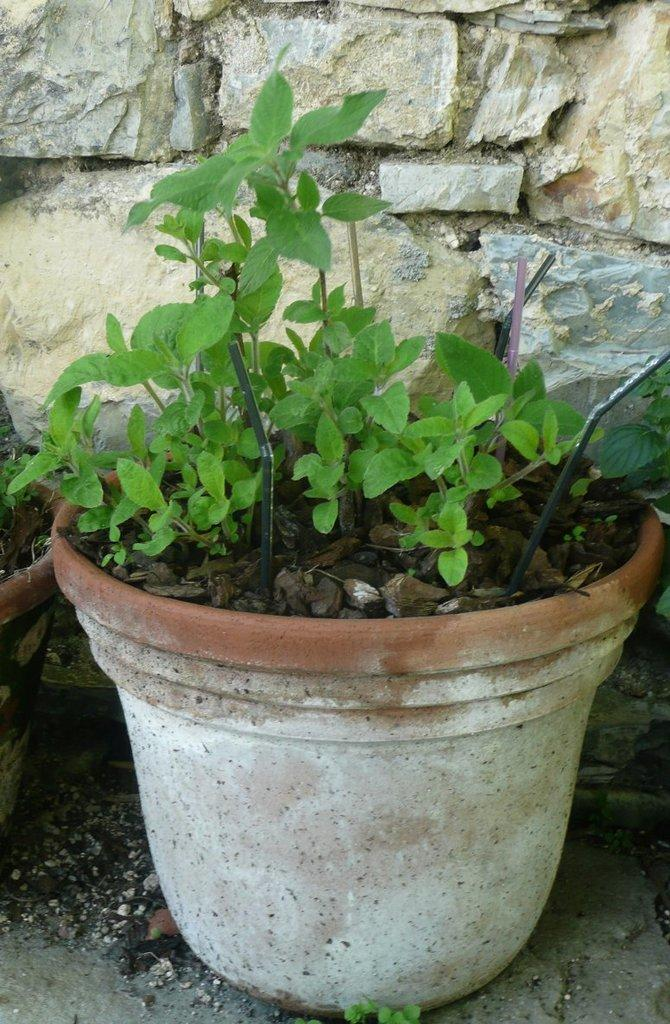How many flower pots are visible in the image? There are two flower pots with plants in the image. Where are the flower pots placed? The flower pots are placed on a surface. What can be seen in the background of the image? There is a wall with stones in the background of the image. What type of sail can be seen in the image? There is no sail present in the image; it features two flower pots with plants and a wall with stones in the background. 